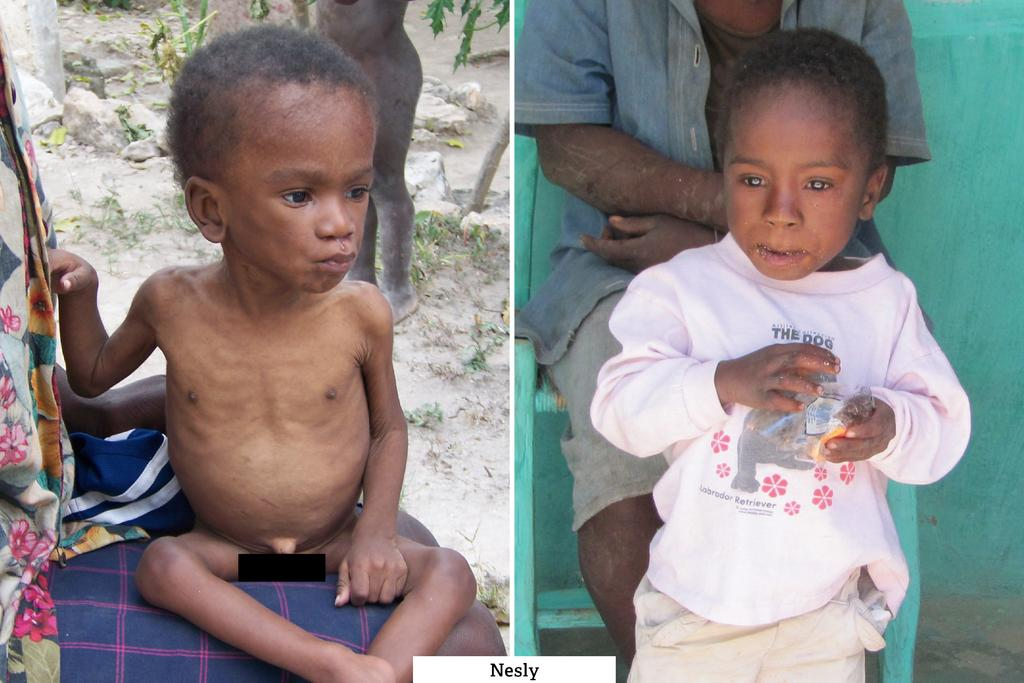What type of artwork is the image? The image is a collage. What can be seen among the various elements in the collage? There are people, rocks, plants, and a wall in the image. Can you describe the natural elements in the collage? There are rocks and plants in the image. What type of structure is visible in the collage? There is a wall in the image. What type of pancake is being served on the wall in the image? There is no pancake present in the image, and the wall does not appear to be serving any food. How many ants can be seen crawling on the people in the image? There are no ants visible in the image; the people are not interacting with any insects. 